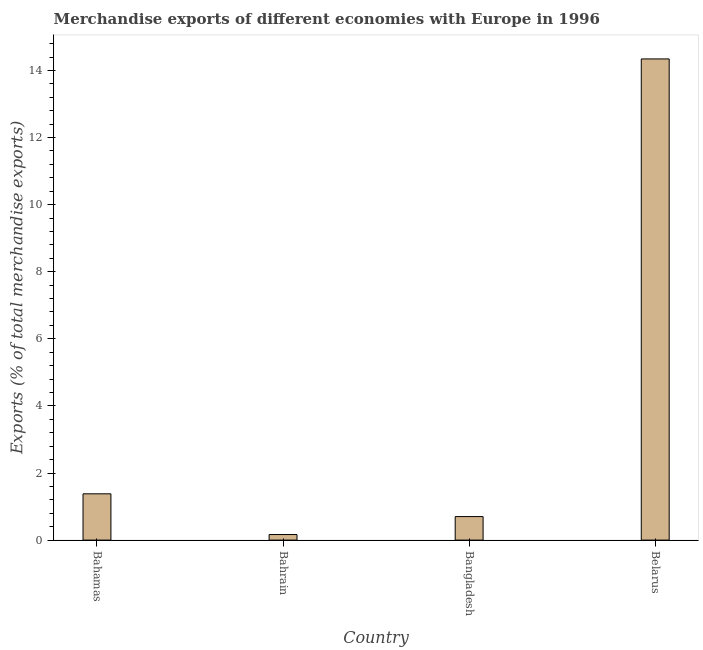Does the graph contain any zero values?
Your answer should be very brief. No. What is the title of the graph?
Give a very brief answer. Merchandise exports of different economies with Europe in 1996. What is the label or title of the Y-axis?
Ensure brevity in your answer.  Exports (% of total merchandise exports). What is the merchandise exports in Belarus?
Your response must be concise. 14.34. Across all countries, what is the maximum merchandise exports?
Give a very brief answer. 14.34. Across all countries, what is the minimum merchandise exports?
Keep it short and to the point. 0.17. In which country was the merchandise exports maximum?
Offer a very short reply. Belarus. In which country was the merchandise exports minimum?
Your response must be concise. Bahrain. What is the sum of the merchandise exports?
Your answer should be very brief. 16.59. What is the difference between the merchandise exports in Bahrain and Belarus?
Make the answer very short. -14.18. What is the average merchandise exports per country?
Keep it short and to the point. 4.15. What is the median merchandise exports?
Ensure brevity in your answer.  1.04. In how many countries, is the merchandise exports greater than 10 %?
Your response must be concise. 1. What is the ratio of the merchandise exports in Bahrain to that in Bangladesh?
Provide a succinct answer. 0.24. Is the merchandise exports in Bahamas less than that in Belarus?
Make the answer very short. Yes. Is the difference between the merchandise exports in Bahamas and Belarus greater than the difference between any two countries?
Offer a very short reply. No. What is the difference between the highest and the second highest merchandise exports?
Your response must be concise. 12.96. Is the sum of the merchandise exports in Bahrain and Bangladesh greater than the maximum merchandise exports across all countries?
Give a very brief answer. No. What is the difference between the highest and the lowest merchandise exports?
Keep it short and to the point. 14.18. In how many countries, is the merchandise exports greater than the average merchandise exports taken over all countries?
Your answer should be very brief. 1. How many bars are there?
Your answer should be very brief. 4. Are the values on the major ticks of Y-axis written in scientific E-notation?
Make the answer very short. No. What is the Exports (% of total merchandise exports) in Bahamas?
Provide a succinct answer. 1.38. What is the Exports (% of total merchandise exports) in Bahrain?
Keep it short and to the point. 0.17. What is the Exports (% of total merchandise exports) of Bangladesh?
Offer a terse response. 0.7. What is the Exports (% of total merchandise exports) in Belarus?
Give a very brief answer. 14.34. What is the difference between the Exports (% of total merchandise exports) in Bahamas and Bahrain?
Keep it short and to the point. 1.21. What is the difference between the Exports (% of total merchandise exports) in Bahamas and Bangladesh?
Provide a succinct answer. 0.68. What is the difference between the Exports (% of total merchandise exports) in Bahamas and Belarus?
Your response must be concise. -12.96. What is the difference between the Exports (% of total merchandise exports) in Bahrain and Bangladesh?
Give a very brief answer. -0.53. What is the difference between the Exports (% of total merchandise exports) in Bahrain and Belarus?
Give a very brief answer. -14.18. What is the difference between the Exports (% of total merchandise exports) in Bangladesh and Belarus?
Make the answer very short. -13.64. What is the ratio of the Exports (% of total merchandise exports) in Bahamas to that in Bahrain?
Give a very brief answer. 8.31. What is the ratio of the Exports (% of total merchandise exports) in Bahamas to that in Bangladesh?
Provide a succinct answer. 1.97. What is the ratio of the Exports (% of total merchandise exports) in Bahamas to that in Belarus?
Your response must be concise. 0.1. What is the ratio of the Exports (% of total merchandise exports) in Bahrain to that in Bangladesh?
Ensure brevity in your answer.  0.24. What is the ratio of the Exports (% of total merchandise exports) in Bahrain to that in Belarus?
Keep it short and to the point. 0.01. What is the ratio of the Exports (% of total merchandise exports) in Bangladesh to that in Belarus?
Give a very brief answer. 0.05. 